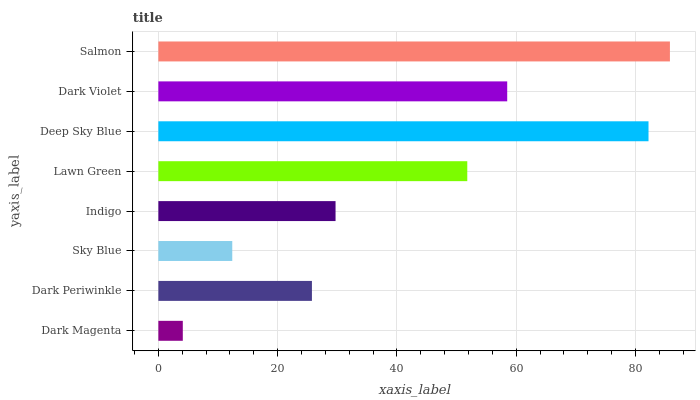Is Dark Magenta the minimum?
Answer yes or no. Yes. Is Salmon the maximum?
Answer yes or no. Yes. Is Dark Periwinkle the minimum?
Answer yes or no. No. Is Dark Periwinkle the maximum?
Answer yes or no. No. Is Dark Periwinkle greater than Dark Magenta?
Answer yes or no. Yes. Is Dark Magenta less than Dark Periwinkle?
Answer yes or no. Yes. Is Dark Magenta greater than Dark Periwinkle?
Answer yes or no. No. Is Dark Periwinkle less than Dark Magenta?
Answer yes or no. No. Is Lawn Green the high median?
Answer yes or no. Yes. Is Indigo the low median?
Answer yes or no. Yes. Is Dark Magenta the high median?
Answer yes or no. No. Is Dark Violet the low median?
Answer yes or no. No. 